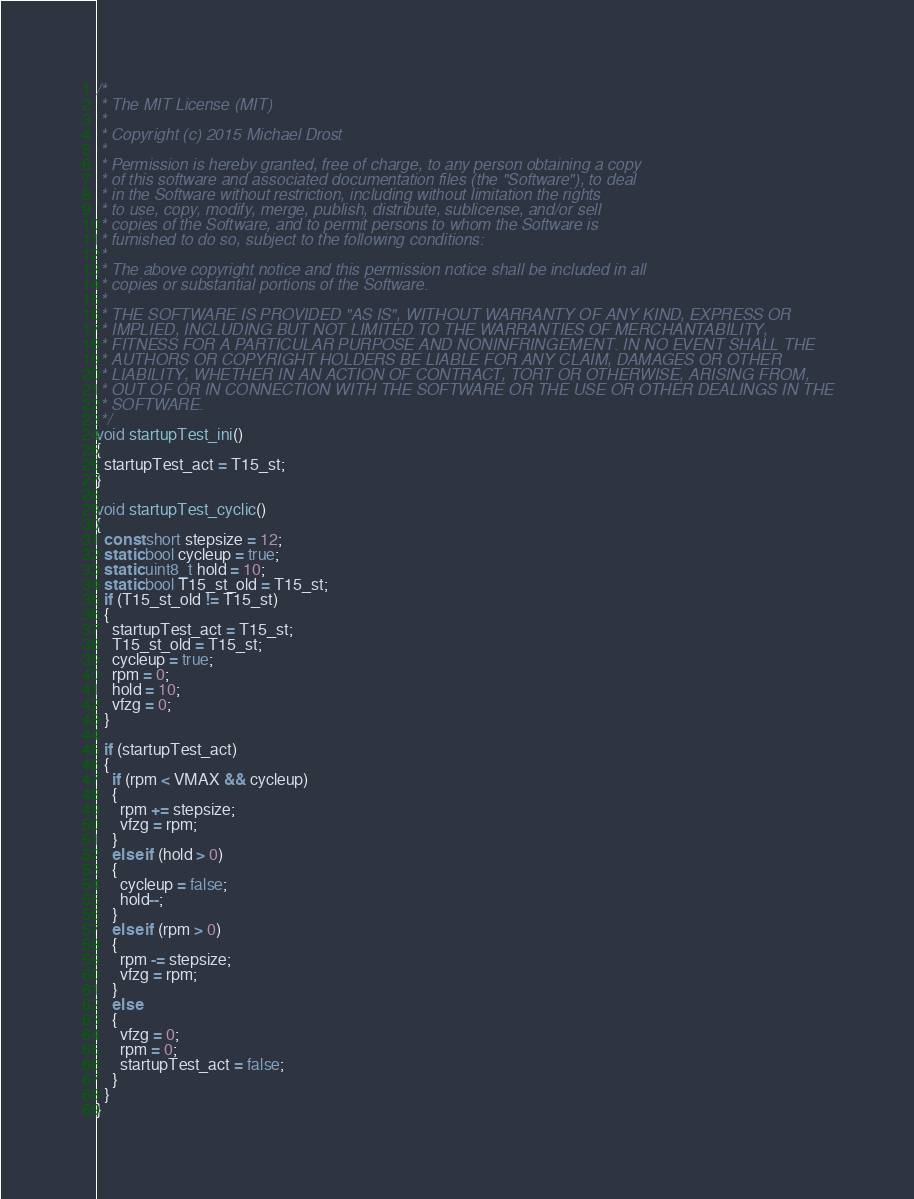<code> <loc_0><loc_0><loc_500><loc_500><_C_>/*
 * The MIT License (MIT)
 *
 * Copyright (c) 2015 Michael Drost
 *
 * Permission is hereby granted, free of charge, to any person obtaining a copy
 * of this software and associated documentation files (the "Software"), to deal
 * in the Software without restriction, including without limitation the rights
 * to use, copy, modify, merge, publish, distribute, sublicense, and/or sell
 * copies of the Software, and to permit persons to whom the Software is
 * furnished to do so, subject to the following conditions:
 *
 * The above copyright notice and this permission notice shall be included in all
 * copies or substantial portions of the Software.
 *
 * THE SOFTWARE IS PROVIDED "AS IS", WITHOUT WARRANTY OF ANY KIND, EXPRESS OR
 * IMPLIED, INCLUDING BUT NOT LIMITED TO THE WARRANTIES OF MERCHANTABILITY,
 * FITNESS FOR A PARTICULAR PURPOSE AND NONINFRINGEMENT. IN NO EVENT SHALL THE
 * AUTHORS OR COPYRIGHT HOLDERS BE LIABLE FOR ANY CLAIM, DAMAGES OR OTHER
 * LIABILITY, WHETHER IN AN ACTION OF CONTRACT, TORT OR OTHERWISE, ARISING FROM,
 * OUT OF OR IN CONNECTION WITH THE SOFTWARE OR THE USE OR OTHER DEALINGS IN THE
 * SOFTWARE.
 */
void startupTest_ini()
{
  startupTest_act = T15_st;
}

void startupTest_cyclic()
{
  const short stepsize = 12;
  static bool cycleup = true;
  static uint8_t hold = 10;
  static bool T15_st_old = T15_st;
  if (T15_st_old != T15_st)
  {
    startupTest_act = T15_st;
    T15_st_old = T15_st;
    cycleup = true;
    rpm = 0;
    hold = 10;
    vfzg = 0;
  }

  if (startupTest_act)
  {
    if (rpm < VMAX && cycleup)
    {
      rpm += stepsize;
      vfzg = rpm;
    }
    else if (hold > 0)
    {
      cycleup = false;
      hold--;
    }
    else if (rpm > 0)
    {
      rpm -= stepsize;
      vfzg = rpm;
    }
    else
    {
      vfzg = 0;
      rpm = 0;
      startupTest_act = false;
    }
  }
}
</code> 